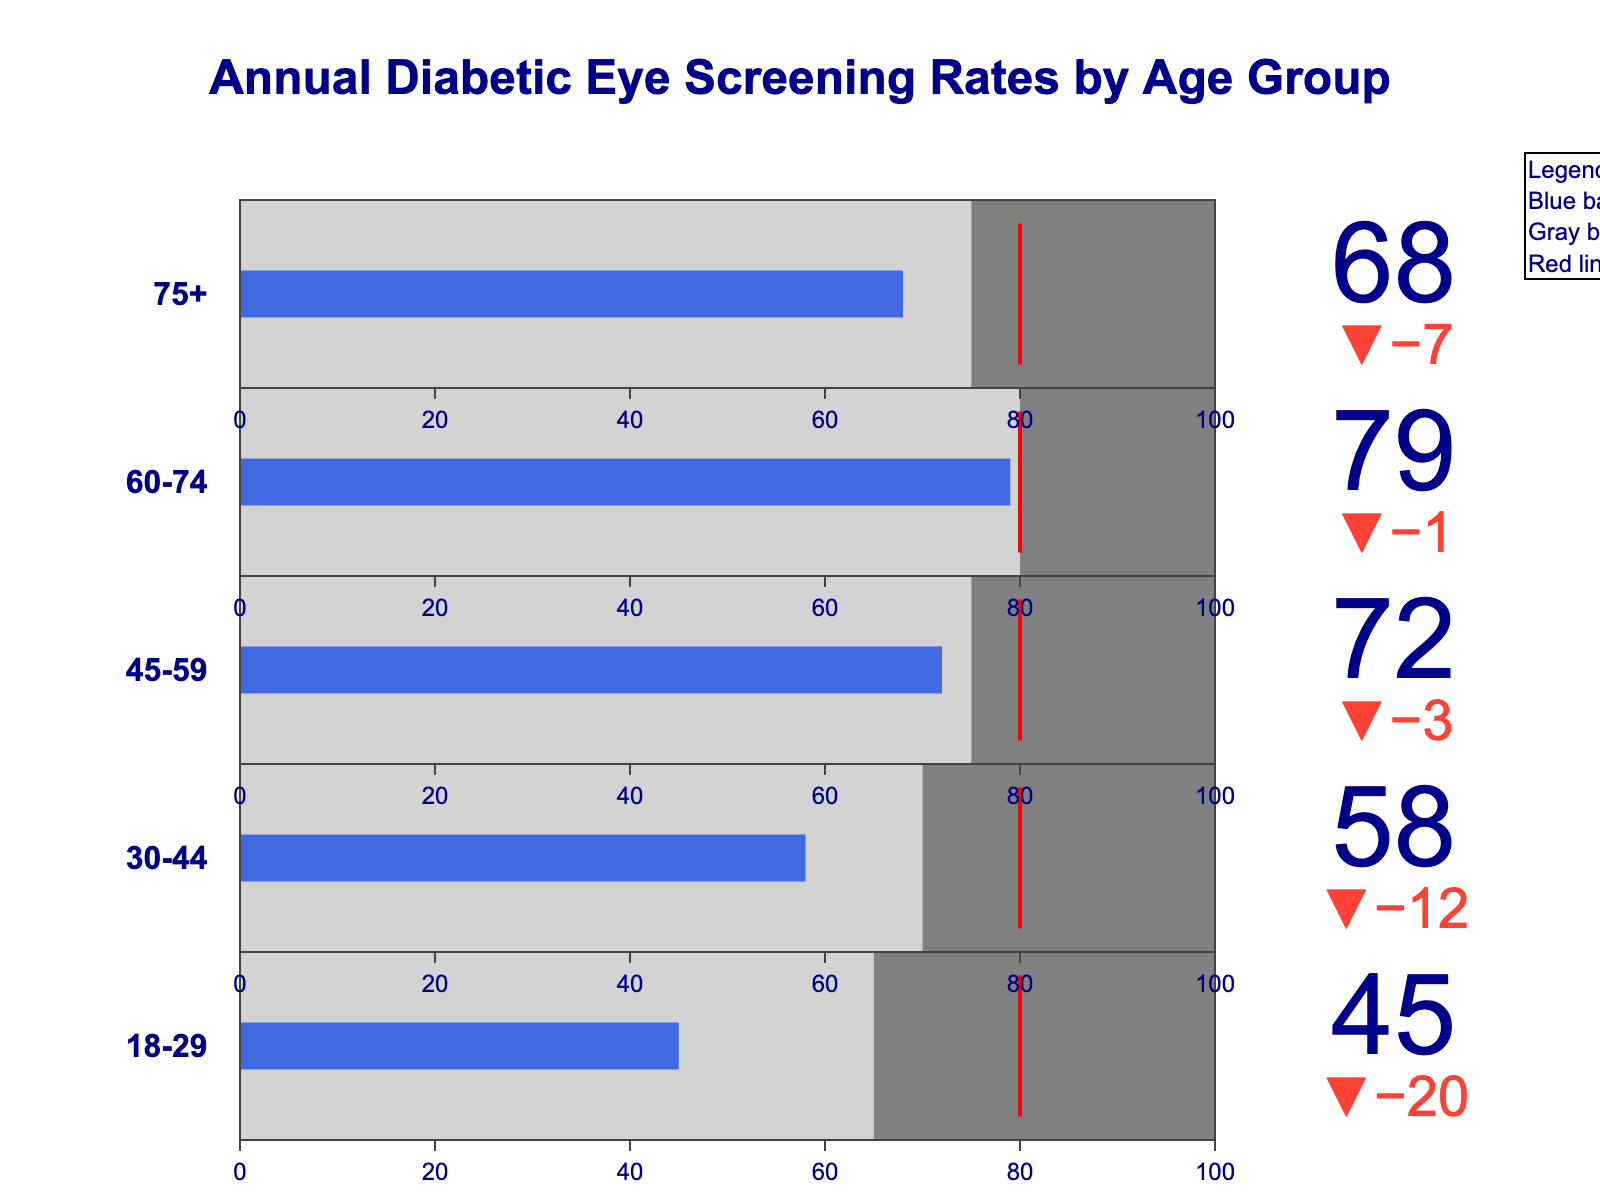What's the overall screening rate trend as age increases? By looking at the bullet chart, we can observe each age group: 18-29 (45), 30-44 (58), 45-59 (72), 60-74 (79), 75+ (68). We see a general increase from 18-29 to 60-74, then a slight decrease at 75+.
Answer: Increase then decrease Which age group has the highest actual screening rate? The actual screening rates are shown on the bullet chart: 18-29 (45), 30-44 (58), 45-59 (72), 60-74 (79), 75+ (68). The highest value is for the 60-74 age group with a rate of 79.
Answer: 60-74 Is the actual screening rate for any age group equal to the guideline recommendation? The guideline recommendation for all age groups is 80. Comparing this with the actual screening rates: 18-29 (45), 30-44 (58), 45-59 (72), 60-74 (79), and 75+ (68), none of the actual rates meet the 80 guideline.
Answer: No What is the difference between the guideline recommendation and the actual screening rate for the 18-29 age group? The guideline recommendation is 80, and the actual screening rate for the 18-29 age group is 45. The difference is 80 - 45.
Answer: 35 Are the actual screening rates above the target rates for all age groups? The target rates and actual screening rates are shown as follows: 18-29 (65/45), 30-44 (70/58), 45-59 (75/72), 60-74 (80/79), 75+ (75/68). In all cases, the actual rates are below the target rates.
Answer: No Which age group is closest to meeting its target rate? Looking at the gaps between actual and target rates: 18-29 (45/65 => -20), 30-44 (58/70 => -12), 45-59 (72/75 => -3), 60-74 (79/80 => -1), 75+ (68/75 => -7). The smallest gap is for the 60-74 age group with a difference of 1.
Answer: 60-74 What is the average target rate across all age groups? Sum of all target rates: 65 + 70 + 75 + 80 + 75 = 365. The number of age groups is 5. The average target rate is 365 / 5.
Answer: 73 Which age group shows the smallest difference between the actual screening rate and its guideline recommendation? To find the smallest difference, we compute: 18-29 (80-45=35), 30-44 (80-58=22), 45-59 (80-72=8), 60-74 (80-79=1), 75+ (80-68=12). The smallest difference is for the 60-74 age group.
Answer: 60-74 In which age group is the difference between actual screening rate and target rate the largest? To find the largest difference: 18-29 (65-45=20), 30-44 (70-58=12), 45-59 (75-72=3), 60-74 (80-79=1), 75+ (75-68=7). The largest difference is for the 18-29 age group.
Answer: 18-29 